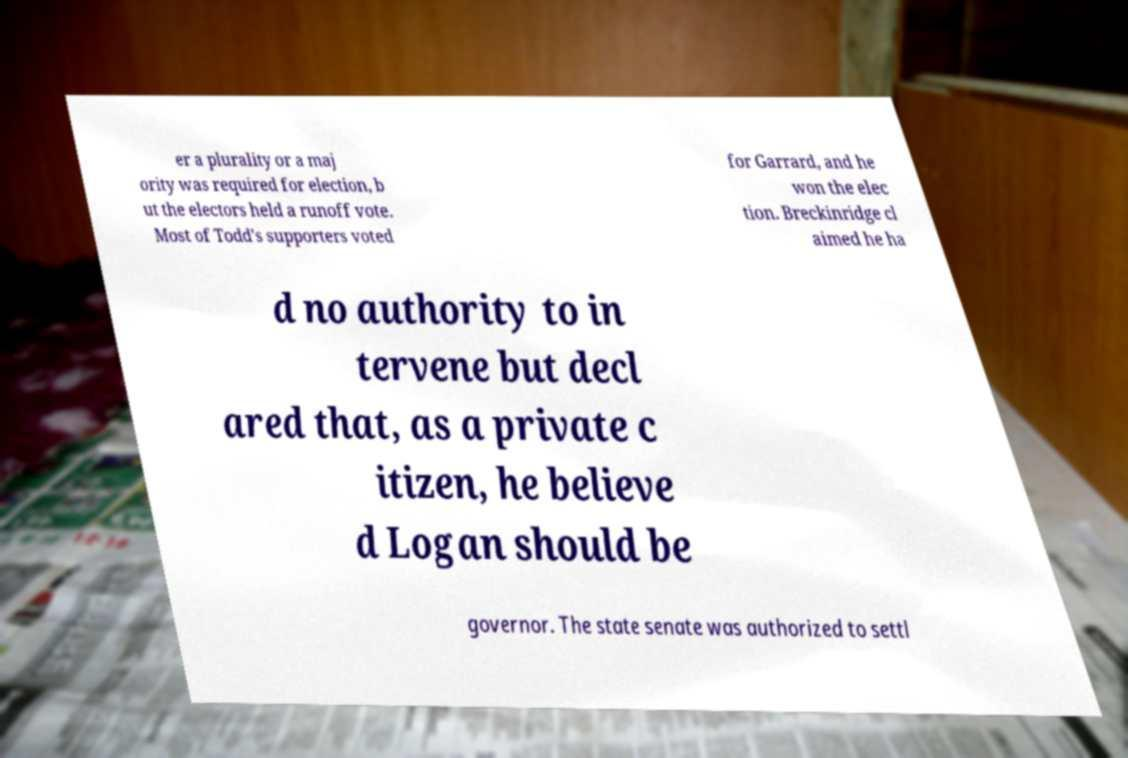Please read and relay the text visible in this image. What does it say? er a plurality or a maj ority was required for election, b ut the electors held a runoff vote. Most of Todd's supporters voted for Garrard, and he won the elec tion. Breckinridge cl aimed he ha d no authority to in tervene but decl ared that, as a private c itizen, he believe d Logan should be governor. The state senate was authorized to settl 